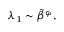Convert formula to latex. <formula><loc_0><loc_0><loc_500><loc_500>\begin{array} { r } { \lambda _ { 1 } \sim \tilde { \beta } ^ { \varphi } , } \end{array}</formula> 